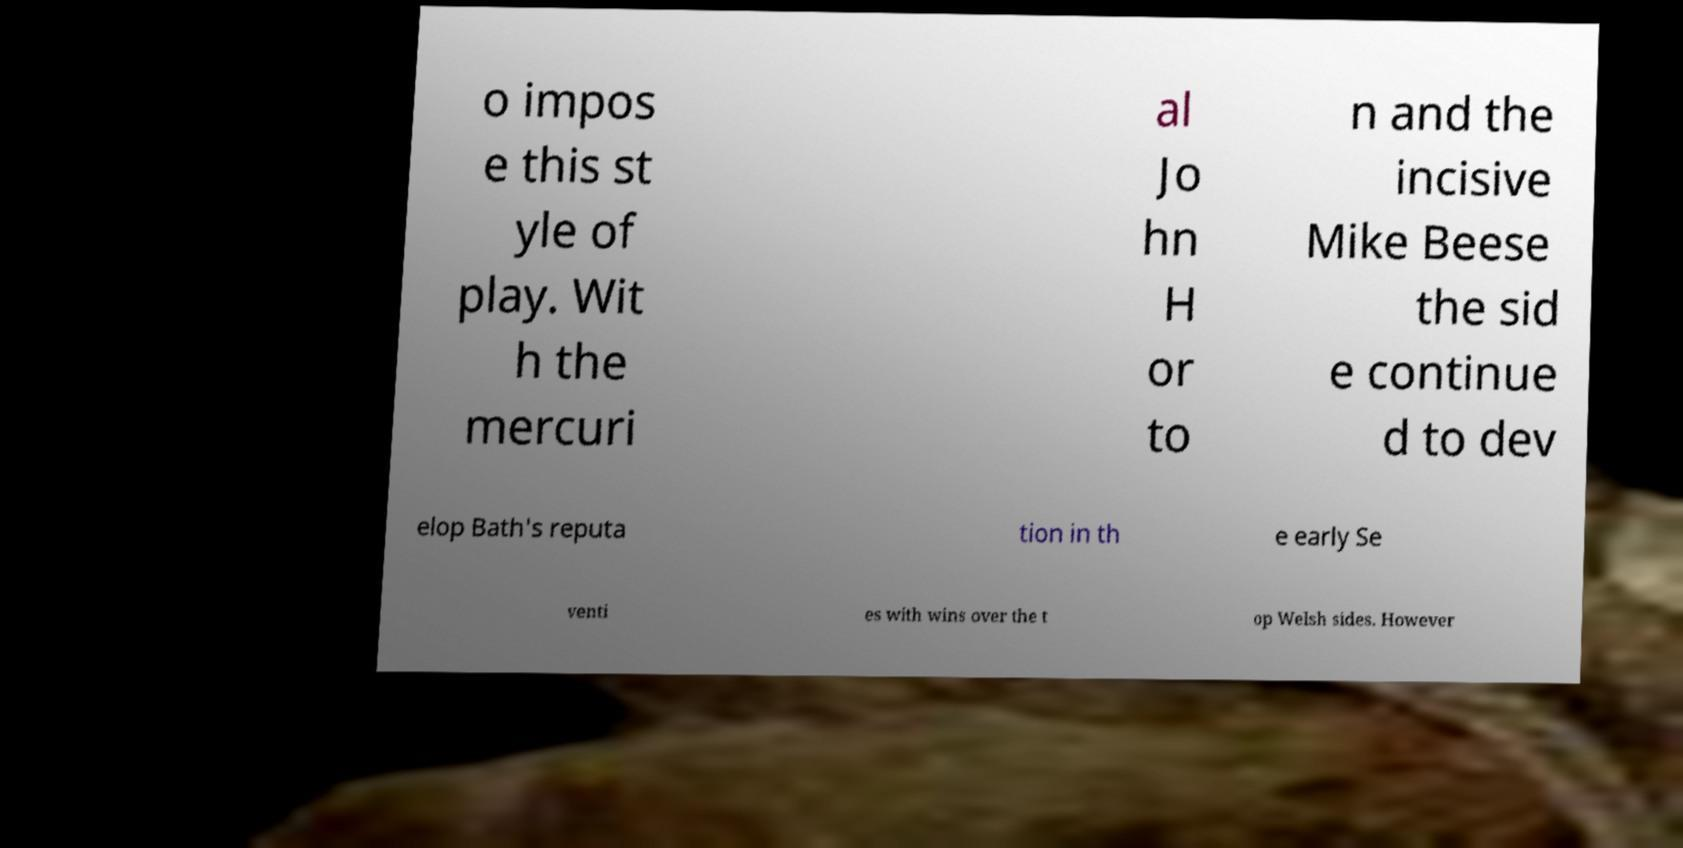I need the written content from this picture converted into text. Can you do that? o impos e this st yle of play. Wit h the mercuri al Jo hn H or to n and the incisive Mike Beese the sid e continue d to dev elop Bath's reputa tion in th e early Se venti es with wins over the t op Welsh sides. However 